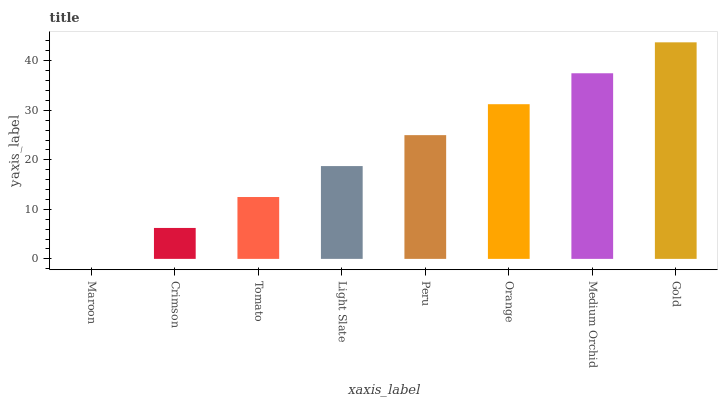Is Maroon the minimum?
Answer yes or no. Yes. Is Gold the maximum?
Answer yes or no. Yes. Is Crimson the minimum?
Answer yes or no. No. Is Crimson the maximum?
Answer yes or no. No. Is Crimson greater than Maroon?
Answer yes or no. Yes. Is Maroon less than Crimson?
Answer yes or no. Yes. Is Maroon greater than Crimson?
Answer yes or no. No. Is Crimson less than Maroon?
Answer yes or no. No. Is Peru the high median?
Answer yes or no. Yes. Is Light Slate the low median?
Answer yes or no. Yes. Is Medium Orchid the high median?
Answer yes or no. No. Is Crimson the low median?
Answer yes or no. No. 